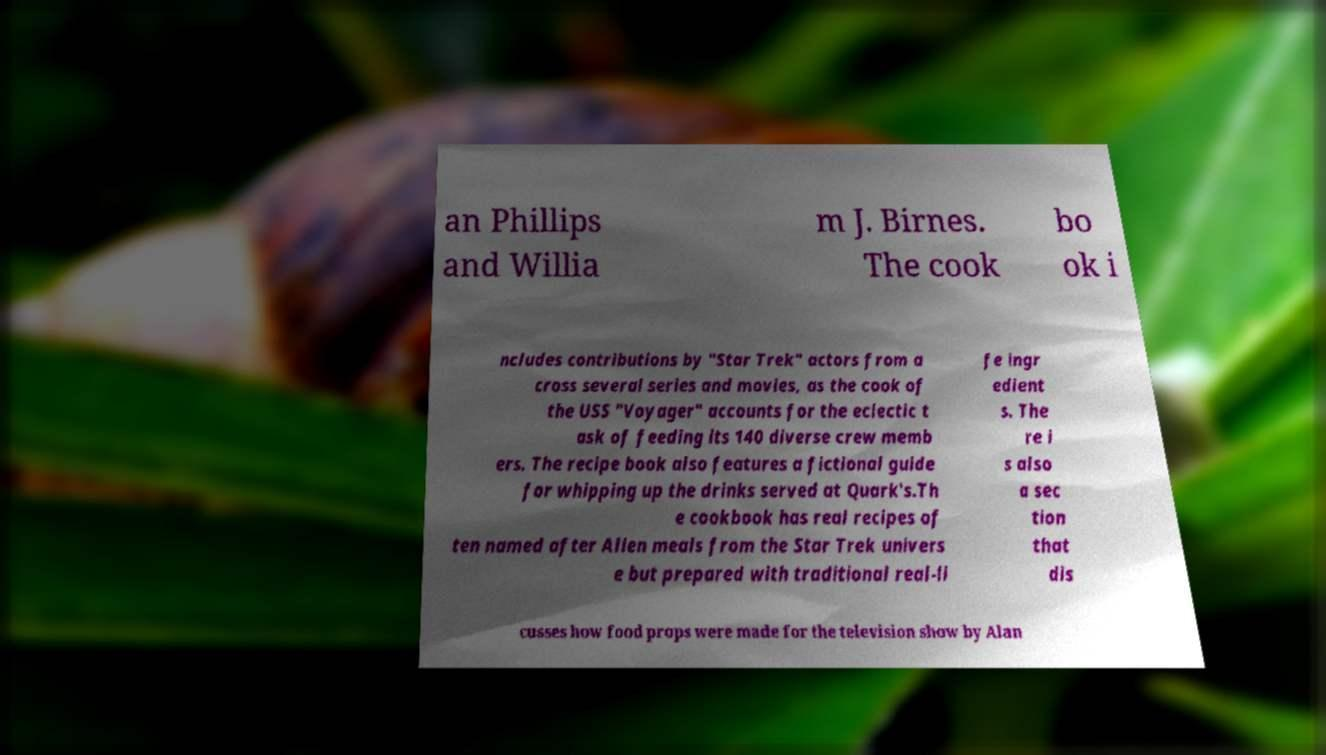Can you read and provide the text displayed in the image?This photo seems to have some interesting text. Can you extract and type it out for me? an Phillips and Willia m J. Birnes. The cook bo ok i ncludes contributions by "Star Trek" actors from a cross several series and movies, as the cook of the USS "Voyager" accounts for the eclectic t ask of feeding its 140 diverse crew memb ers. The recipe book also features a fictional guide for whipping up the drinks served at Quark's.Th e cookbook has real recipes of ten named after Alien meals from the Star Trek univers e but prepared with traditional real-li fe ingr edient s. The re i s also a sec tion that dis cusses how food props were made for the television show by Alan 